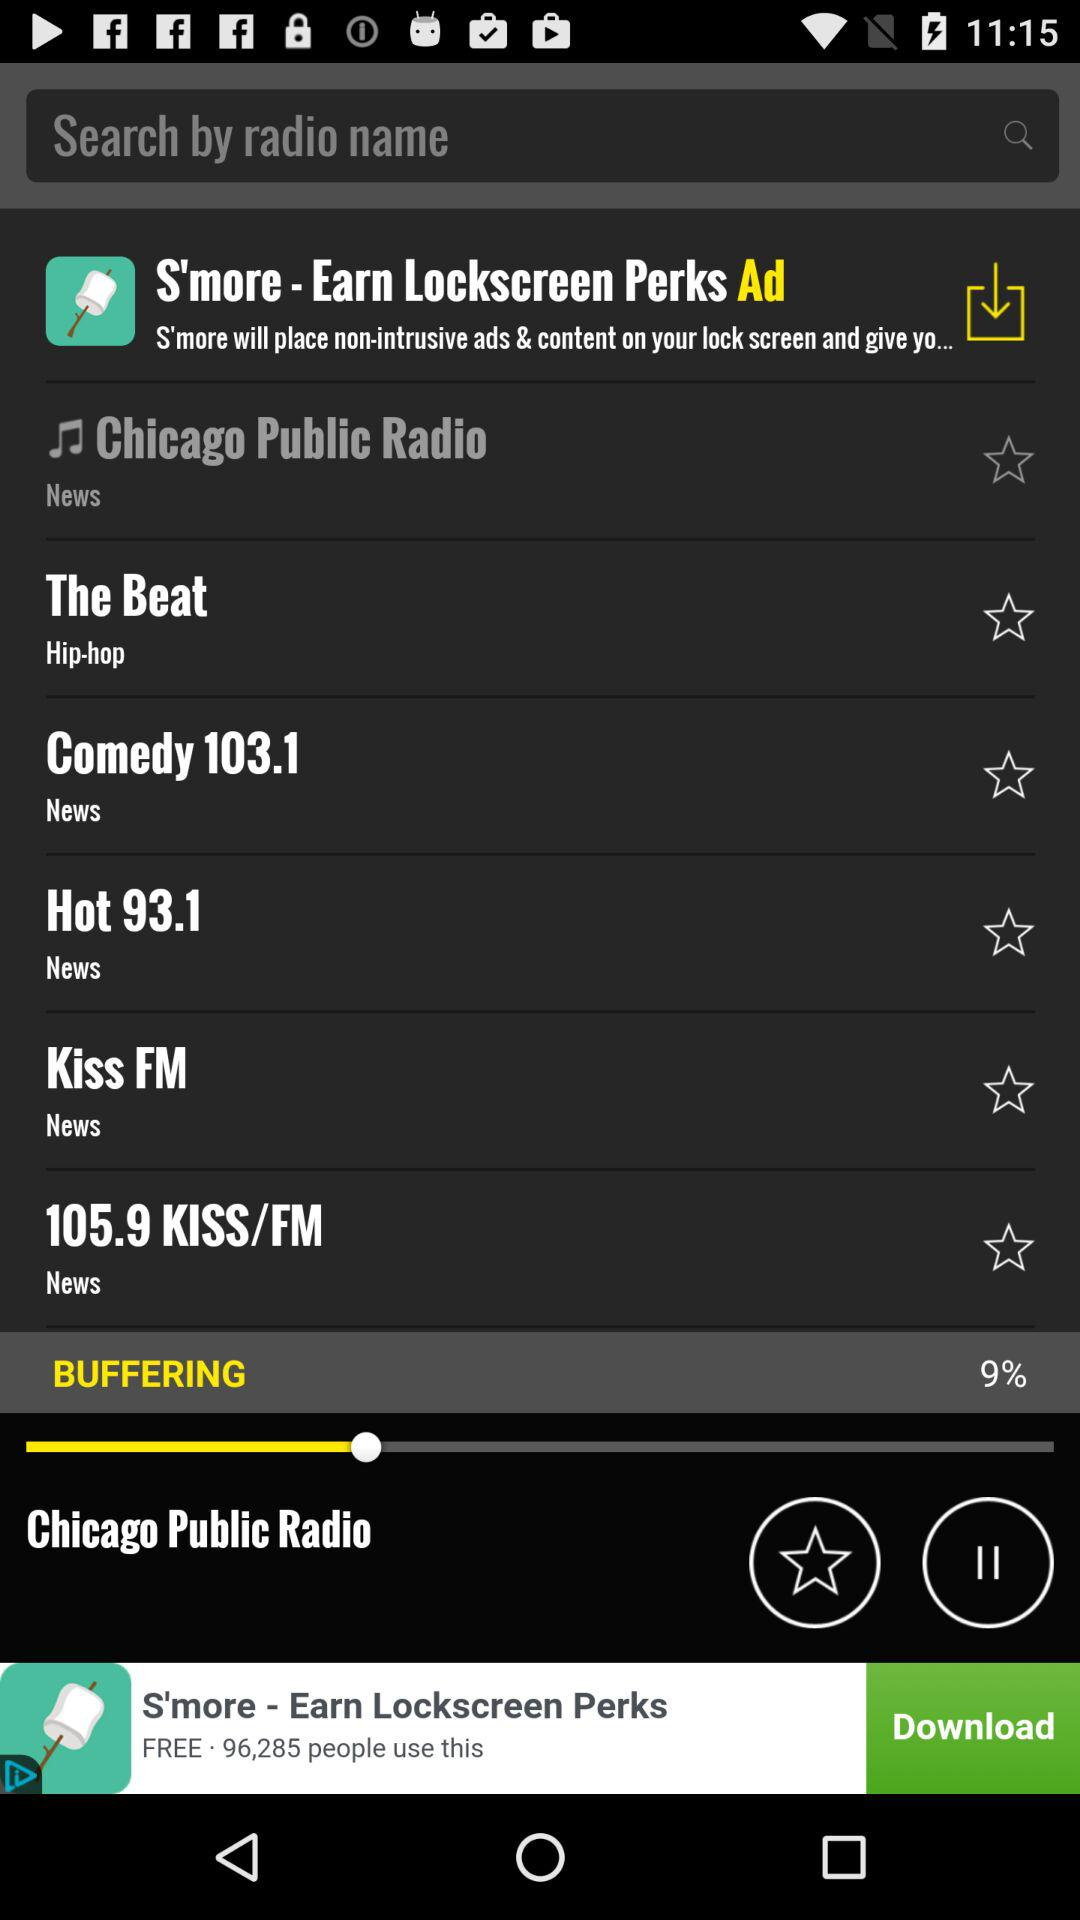What is the percentage of buffering? The percentage of buffering is 9. 